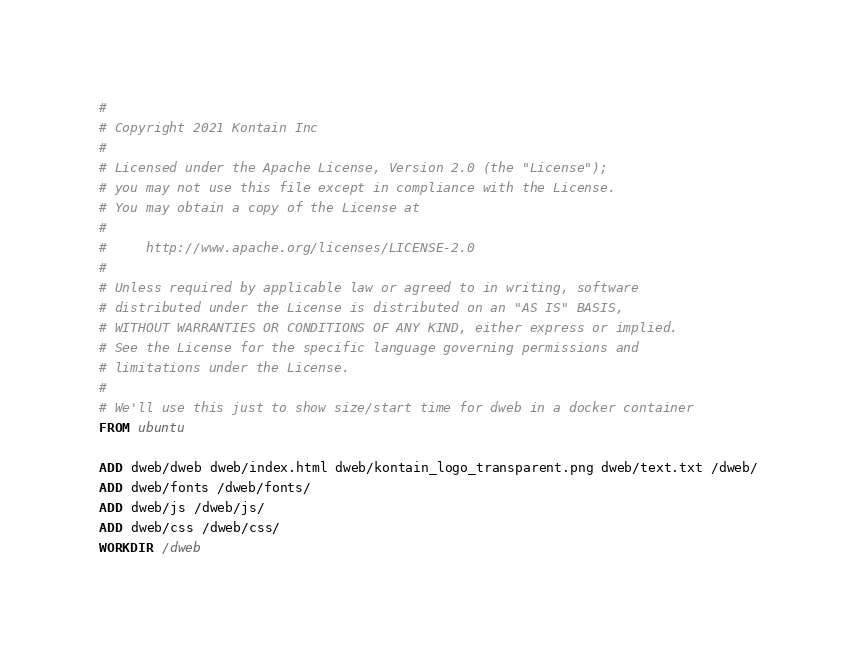Convert code to text. <code><loc_0><loc_0><loc_500><loc_500><_Dockerfile_>#
# Copyright 2021 Kontain Inc
#
# Licensed under the Apache License, Version 2.0 (the "License");
# you may not use this file except in compliance with the License.
# You may obtain a copy of the License at
#
#     http://www.apache.org/licenses/LICENSE-2.0
#
# Unless required by applicable law or agreed to in writing, software
# distributed under the License is distributed on an "AS IS" BASIS,
# WITHOUT WARRANTIES OR CONDITIONS OF ANY KIND, either express or implied.
# See the License for the specific language governing permissions and
# limitations under the License.
#
# We'll use this just to show size/start time for dweb in a docker container
FROM ubuntu

ADD dweb/dweb dweb/index.html dweb/kontain_logo_transparent.png dweb/text.txt /dweb/
ADD dweb/fonts /dweb/fonts/
ADD dweb/js /dweb/js/
ADD dweb/css /dweb/css/
WORKDIR /dweb
</code> 